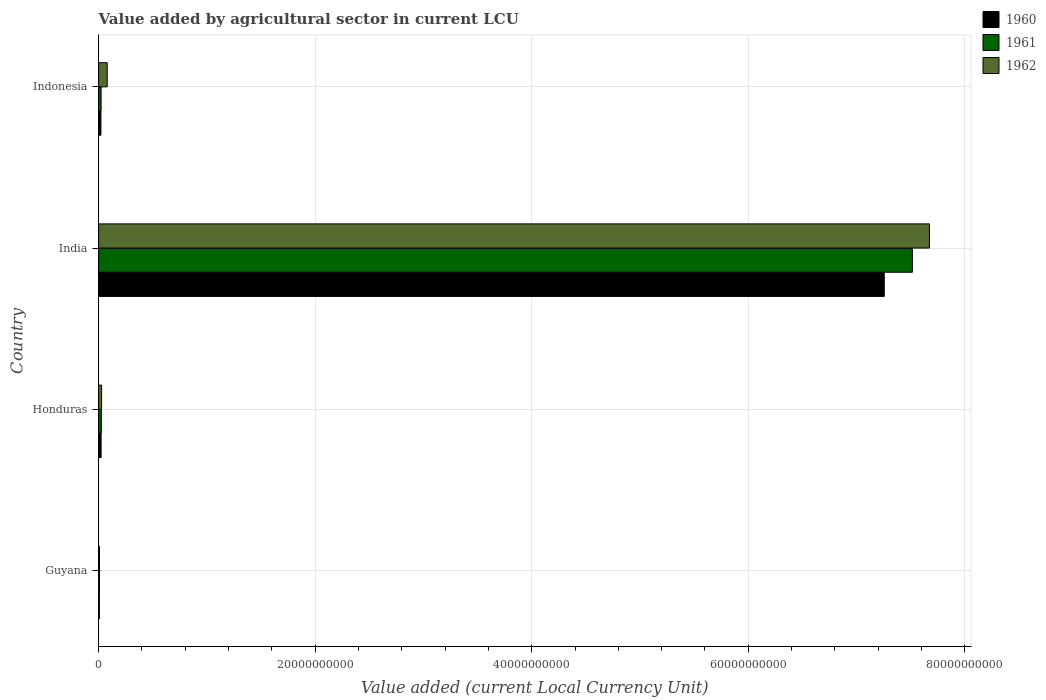How many different coloured bars are there?
Your answer should be compact. 3. How many groups of bars are there?
Your response must be concise. 4. Are the number of bars per tick equal to the number of legend labels?
Your answer should be compact. Yes. How many bars are there on the 1st tick from the bottom?
Ensure brevity in your answer.  3. What is the label of the 3rd group of bars from the top?
Your answer should be very brief. Honduras. What is the value added by agricultural sector in 1961 in India?
Your answer should be very brief. 7.52e+1. Across all countries, what is the maximum value added by agricultural sector in 1960?
Offer a very short reply. 7.26e+1. Across all countries, what is the minimum value added by agricultural sector in 1961?
Your response must be concise. 7.60e+07. In which country was the value added by agricultural sector in 1961 minimum?
Offer a very short reply. Guyana. What is the total value added by agricultural sector in 1960 in the graph?
Your answer should be compact. 7.31e+1. What is the difference between the value added by agricultural sector in 1960 in Guyana and that in India?
Your answer should be compact. -7.25e+1. What is the difference between the value added by agricultural sector in 1961 in India and the value added by agricultural sector in 1962 in Indonesia?
Provide a succinct answer. 7.44e+1. What is the average value added by agricultural sector in 1962 per country?
Provide a short and direct response. 1.95e+1. What is the difference between the value added by agricultural sector in 1960 and value added by agricultural sector in 1961 in Honduras?
Provide a short and direct response. -2.42e+07. In how many countries, is the value added by agricultural sector in 1960 greater than 16000000000 LCU?
Offer a very short reply. 1. What is the ratio of the value added by agricultural sector in 1962 in Guyana to that in Indonesia?
Provide a succinct answer. 0.1. Is the value added by agricultural sector in 1960 in Guyana less than that in Indonesia?
Provide a succinct answer. Yes. Is the difference between the value added by agricultural sector in 1960 in Guyana and India greater than the difference between the value added by agricultural sector in 1961 in Guyana and India?
Offer a terse response. Yes. What is the difference between the highest and the second highest value added by agricultural sector in 1960?
Provide a succinct answer. 7.23e+1. What is the difference between the highest and the lowest value added by agricultural sector in 1960?
Keep it short and to the point. 7.25e+1. In how many countries, is the value added by agricultural sector in 1962 greater than the average value added by agricultural sector in 1962 taken over all countries?
Provide a succinct answer. 1. What does the 1st bar from the top in India represents?
Your response must be concise. 1962. What does the 3rd bar from the bottom in Guyana represents?
Your answer should be compact. 1962. Are all the bars in the graph horizontal?
Your answer should be very brief. Yes. How many countries are there in the graph?
Provide a succinct answer. 4. Are the values on the major ticks of X-axis written in scientific E-notation?
Keep it short and to the point. No. What is the title of the graph?
Make the answer very short. Value added by agricultural sector in current LCU. What is the label or title of the X-axis?
Provide a short and direct response. Value added (current Local Currency Unit). What is the label or title of the Y-axis?
Provide a short and direct response. Country. What is the Value added (current Local Currency Unit) of 1960 in Guyana?
Keep it short and to the point. 6.88e+07. What is the Value added (current Local Currency Unit) of 1961 in Guyana?
Provide a succinct answer. 7.60e+07. What is the Value added (current Local Currency Unit) in 1962 in Guyana?
Offer a terse response. 7.84e+07. What is the Value added (current Local Currency Unit) in 1960 in Honduras?
Provide a succinct answer. 2.27e+08. What is the Value added (current Local Currency Unit) in 1961 in Honduras?
Your answer should be compact. 2.51e+08. What is the Value added (current Local Currency Unit) of 1962 in Honduras?
Offer a terse response. 2.74e+08. What is the Value added (current Local Currency Unit) of 1960 in India?
Offer a very short reply. 7.26e+1. What is the Value added (current Local Currency Unit) of 1961 in India?
Offer a terse response. 7.52e+1. What is the Value added (current Local Currency Unit) in 1962 in India?
Provide a succinct answer. 7.67e+1. What is the Value added (current Local Currency Unit) of 1960 in Indonesia?
Your answer should be very brief. 2.12e+08. What is the Value added (current Local Currency Unit) in 1961 in Indonesia?
Provide a succinct answer. 2.27e+08. What is the Value added (current Local Currency Unit) in 1962 in Indonesia?
Provide a short and direct response. 7.93e+08. Across all countries, what is the maximum Value added (current Local Currency Unit) in 1960?
Give a very brief answer. 7.26e+1. Across all countries, what is the maximum Value added (current Local Currency Unit) in 1961?
Offer a very short reply. 7.52e+1. Across all countries, what is the maximum Value added (current Local Currency Unit) of 1962?
Ensure brevity in your answer.  7.67e+1. Across all countries, what is the minimum Value added (current Local Currency Unit) of 1960?
Your answer should be very brief. 6.88e+07. Across all countries, what is the minimum Value added (current Local Currency Unit) of 1961?
Ensure brevity in your answer.  7.60e+07. Across all countries, what is the minimum Value added (current Local Currency Unit) in 1962?
Your answer should be compact. 7.84e+07. What is the total Value added (current Local Currency Unit) of 1960 in the graph?
Make the answer very short. 7.31e+1. What is the total Value added (current Local Currency Unit) in 1961 in the graph?
Offer a terse response. 7.57e+1. What is the total Value added (current Local Currency Unit) in 1962 in the graph?
Provide a short and direct response. 7.79e+1. What is the difference between the Value added (current Local Currency Unit) of 1960 in Guyana and that in Honduras?
Offer a terse response. -1.58e+08. What is the difference between the Value added (current Local Currency Unit) in 1961 in Guyana and that in Honduras?
Ensure brevity in your answer.  -1.75e+08. What is the difference between the Value added (current Local Currency Unit) of 1962 in Guyana and that in Honduras?
Make the answer very short. -1.96e+08. What is the difference between the Value added (current Local Currency Unit) of 1960 in Guyana and that in India?
Ensure brevity in your answer.  -7.25e+1. What is the difference between the Value added (current Local Currency Unit) of 1961 in Guyana and that in India?
Offer a terse response. -7.51e+1. What is the difference between the Value added (current Local Currency Unit) of 1962 in Guyana and that in India?
Provide a succinct answer. -7.67e+1. What is the difference between the Value added (current Local Currency Unit) of 1960 in Guyana and that in Indonesia?
Give a very brief answer. -1.43e+08. What is the difference between the Value added (current Local Currency Unit) of 1961 in Guyana and that in Indonesia?
Ensure brevity in your answer.  -1.51e+08. What is the difference between the Value added (current Local Currency Unit) of 1962 in Guyana and that in Indonesia?
Keep it short and to the point. -7.15e+08. What is the difference between the Value added (current Local Currency Unit) of 1960 in Honduras and that in India?
Make the answer very short. -7.23e+1. What is the difference between the Value added (current Local Currency Unit) of 1961 in Honduras and that in India?
Keep it short and to the point. -7.49e+1. What is the difference between the Value added (current Local Currency Unit) of 1962 in Honduras and that in India?
Keep it short and to the point. -7.65e+1. What is the difference between the Value added (current Local Currency Unit) in 1960 in Honduras and that in Indonesia?
Ensure brevity in your answer.  1.50e+07. What is the difference between the Value added (current Local Currency Unit) of 1961 in Honduras and that in Indonesia?
Provide a short and direct response. 2.42e+07. What is the difference between the Value added (current Local Currency Unit) of 1962 in Honduras and that in Indonesia?
Provide a succinct answer. -5.18e+08. What is the difference between the Value added (current Local Currency Unit) of 1960 in India and that in Indonesia?
Make the answer very short. 7.24e+1. What is the difference between the Value added (current Local Currency Unit) of 1961 in India and that in Indonesia?
Make the answer very short. 7.49e+1. What is the difference between the Value added (current Local Currency Unit) in 1962 in India and that in Indonesia?
Give a very brief answer. 7.59e+1. What is the difference between the Value added (current Local Currency Unit) in 1960 in Guyana and the Value added (current Local Currency Unit) in 1961 in Honduras?
Make the answer very short. -1.82e+08. What is the difference between the Value added (current Local Currency Unit) of 1960 in Guyana and the Value added (current Local Currency Unit) of 1962 in Honduras?
Make the answer very short. -2.06e+08. What is the difference between the Value added (current Local Currency Unit) in 1961 in Guyana and the Value added (current Local Currency Unit) in 1962 in Honduras?
Provide a succinct answer. -1.98e+08. What is the difference between the Value added (current Local Currency Unit) of 1960 in Guyana and the Value added (current Local Currency Unit) of 1961 in India?
Keep it short and to the point. -7.51e+1. What is the difference between the Value added (current Local Currency Unit) in 1960 in Guyana and the Value added (current Local Currency Unit) in 1962 in India?
Give a very brief answer. -7.67e+1. What is the difference between the Value added (current Local Currency Unit) in 1961 in Guyana and the Value added (current Local Currency Unit) in 1962 in India?
Offer a terse response. -7.67e+1. What is the difference between the Value added (current Local Currency Unit) in 1960 in Guyana and the Value added (current Local Currency Unit) in 1961 in Indonesia?
Your answer should be compact. -1.58e+08. What is the difference between the Value added (current Local Currency Unit) in 1960 in Guyana and the Value added (current Local Currency Unit) in 1962 in Indonesia?
Your answer should be compact. -7.24e+08. What is the difference between the Value added (current Local Currency Unit) of 1961 in Guyana and the Value added (current Local Currency Unit) of 1962 in Indonesia?
Ensure brevity in your answer.  -7.17e+08. What is the difference between the Value added (current Local Currency Unit) of 1960 in Honduras and the Value added (current Local Currency Unit) of 1961 in India?
Offer a very short reply. -7.49e+1. What is the difference between the Value added (current Local Currency Unit) of 1960 in Honduras and the Value added (current Local Currency Unit) of 1962 in India?
Provide a short and direct response. -7.65e+1. What is the difference between the Value added (current Local Currency Unit) in 1961 in Honduras and the Value added (current Local Currency Unit) in 1962 in India?
Provide a short and direct response. -7.65e+1. What is the difference between the Value added (current Local Currency Unit) in 1960 in Honduras and the Value added (current Local Currency Unit) in 1961 in Indonesia?
Give a very brief answer. 0. What is the difference between the Value added (current Local Currency Unit) of 1960 in Honduras and the Value added (current Local Currency Unit) of 1962 in Indonesia?
Your answer should be very brief. -5.66e+08. What is the difference between the Value added (current Local Currency Unit) in 1961 in Honduras and the Value added (current Local Currency Unit) in 1962 in Indonesia?
Offer a very short reply. -5.42e+08. What is the difference between the Value added (current Local Currency Unit) of 1960 in India and the Value added (current Local Currency Unit) of 1961 in Indonesia?
Keep it short and to the point. 7.23e+1. What is the difference between the Value added (current Local Currency Unit) of 1960 in India and the Value added (current Local Currency Unit) of 1962 in Indonesia?
Provide a short and direct response. 7.18e+1. What is the difference between the Value added (current Local Currency Unit) of 1961 in India and the Value added (current Local Currency Unit) of 1962 in Indonesia?
Keep it short and to the point. 7.44e+1. What is the average Value added (current Local Currency Unit) in 1960 per country?
Make the answer very short. 1.83e+1. What is the average Value added (current Local Currency Unit) in 1961 per country?
Ensure brevity in your answer.  1.89e+1. What is the average Value added (current Local Currency Unit) in 1962 per country?
Keep it short and to the point. 1.95e+1. What is the difference between the Value added (current Local Currency Unit) in 1960 and Value added (current Local Currency Unit) in 1961 in Guyana?
Your answer should be very brief. -7.20e+06. What is the difference between the Value added (current Local Currency Unit) in 1960 and Value added (current Local Currency Unit) in 1962 in Guyana?
Your response must be concise. -9.60e+06. What is the difference between the Value added (current Local Currency Unit) in 1961 and Value added (current Local Currency Unit) in 1962 in Guyana?
Offer a very short reply. -2.40e+06. What is the difference between the Value added (current Local Currency Unit) in 1960 and Value added (current Local Currency Unit) in 1961 in Honduras?
Keep it short and to the point. -2.42e+07. What is the difference between the Value added (current Local Currency Unit) of 1960 and Value added (current Local Currency Unit) of 1962 in Honduras?
Give a very brief answer. -4.75e+07. What is the difference between the Value added (current Local Currency Unit) in 1961 and Value added (current Local Currency Unit) in 1962 in Honduras?
Offer a terse response. -2.33e+07. What is the difference between the Value added (current Local Currency Unit) in 1960 and Value added (current Local Currency Unit) in 1961 in India?
Give a very brief answer. -2.59e+09. What is the difference between the Value added (current Local Currency Unit) of 1960 and Value added (current Local Currency Unit) of 1962 in India?
Provide a short and direct response. -4.17e+09. What is the difference between the Value added (current Local Currency Unit) in 1961 and Value added (current Local Currency Unit) in 1962 in India?
Offer a very short reply. -1.58e+09. What is the difference between the Value added (current Local Currency Unit) of 1960 and Value added (current Local Currency Unit) of 1961 in Indonesia?
Provide a short and direct response. -1.50e+07. What is the difference between the Value added (current Local Currency Unit) in 1960 and Value added (current Local Currency Unit) in 1962 in Indonesia?
Give a very brief answer. -5.81e+08. What is the difference between the Value added (current Local Currency Unit) in 1961 and Value added (current Local Currency Unit) in 1962 in Indonesia?
Offer a terse response. -5.66e+08. What is the ratio of the Value added (current Local Currency Unit) of 1960 in Guyana to that in Honduras?
Give a very brief answer. 0.3. What is the ratio of the Value added (current Local Currency Unit) in 1961 in Guyana to that in Honduras?
Your answer should be compact. 0.3. What is the ratio of the Value added (current Local Currency Unit) of 1962 in Guyana to that in Honduras?
Give a very brief answer. 0.29. What is the ratio of the Value added (current Local Currency Unit) in 1960 in Guyana to that in India?
Keep it short and to the point. 0. What is the ratio of the Value added (current Local Currency Unit) of 1960 in Guyana to that in Indonesia?
Your answer should be very brief. 0.32. What is the ratio of the Value added (current Local Currency Unit) in 1961 in Guyana to that in Indonesia?
Offer a terse response. 0.33. What is the ratio of the Value added (current Local Currency Unit) of 1962 in Guyana to that in Indonesia?
Ensure brevity in your answer.  0.1. What is the ratio of the Value added (current Local Currency Unit) of 1960 in Honduras to that in India?
Keep it short and to the point. 0. What is the ratio of the Value added (current Local Currency Unit) of 1961 in Honduras to that in India?
Provide a succinct answer. 0. What is the ratio of the Value added (current Local Currency Unit) in 1962 in Honduras to that in India?
Your answer should be very brief. 0. What is the ratio of the Value added (current Local Currency Unit) in 1960 in Honduras to that in Indonesia?
Your response must be concise. 1.07. What is the ratio of the Value added (current Local Currency Unit) in 1961 in Honduras to that in Indonesia?
Provide a short and direct response. 1.11. What is the ratio of the Value added (current Local Currency Unit) of 1962 in Honduras to that in Indonesia?
Make the answer very short. 0.35. What is the ratio of the Value added (current Local Currency Unit) of 1960 in India to that in Indonesia?
Your response must be concise. 342.29. What is the ratio of the Value added (current Local Currency Unit) of 1961 in India to that in Indonesia?
Your response must be concise. 331.1. What is the ratio of the Value added (current Local Currency Unit) of 1962 in India to that in Indonesia?
Provide a succinct answer. 96.77. What is the difference between the highest and the second highest Value added (current Local Currency Unit) in 1960?
Give a very brief answer. 7.23e+1. What is the difference between the highest and the second highest Value added (current Local Currency Unit) in 1961?
Ensure brevity in your answer.  7.49e+1. What is the difference between the highest and the second highest Value added (current Local Currency Unit) of 1962?
Keep it short and to the point. 7.59e+1. What is the difference between the highest and the lowest Value added (current Local Currency Unit) in 1960?
Provide a short and direct response. 7.25e+1. What is the difference between the highest and the lowest Value added (current Local Currency Unit) of 1961?
Make the answer very short. 7.51e+1. What is the difference between the highest and the lowest Value added (current Local Currency Unit) of 1962?
Provide a succinct answer. 7.67e+1. 